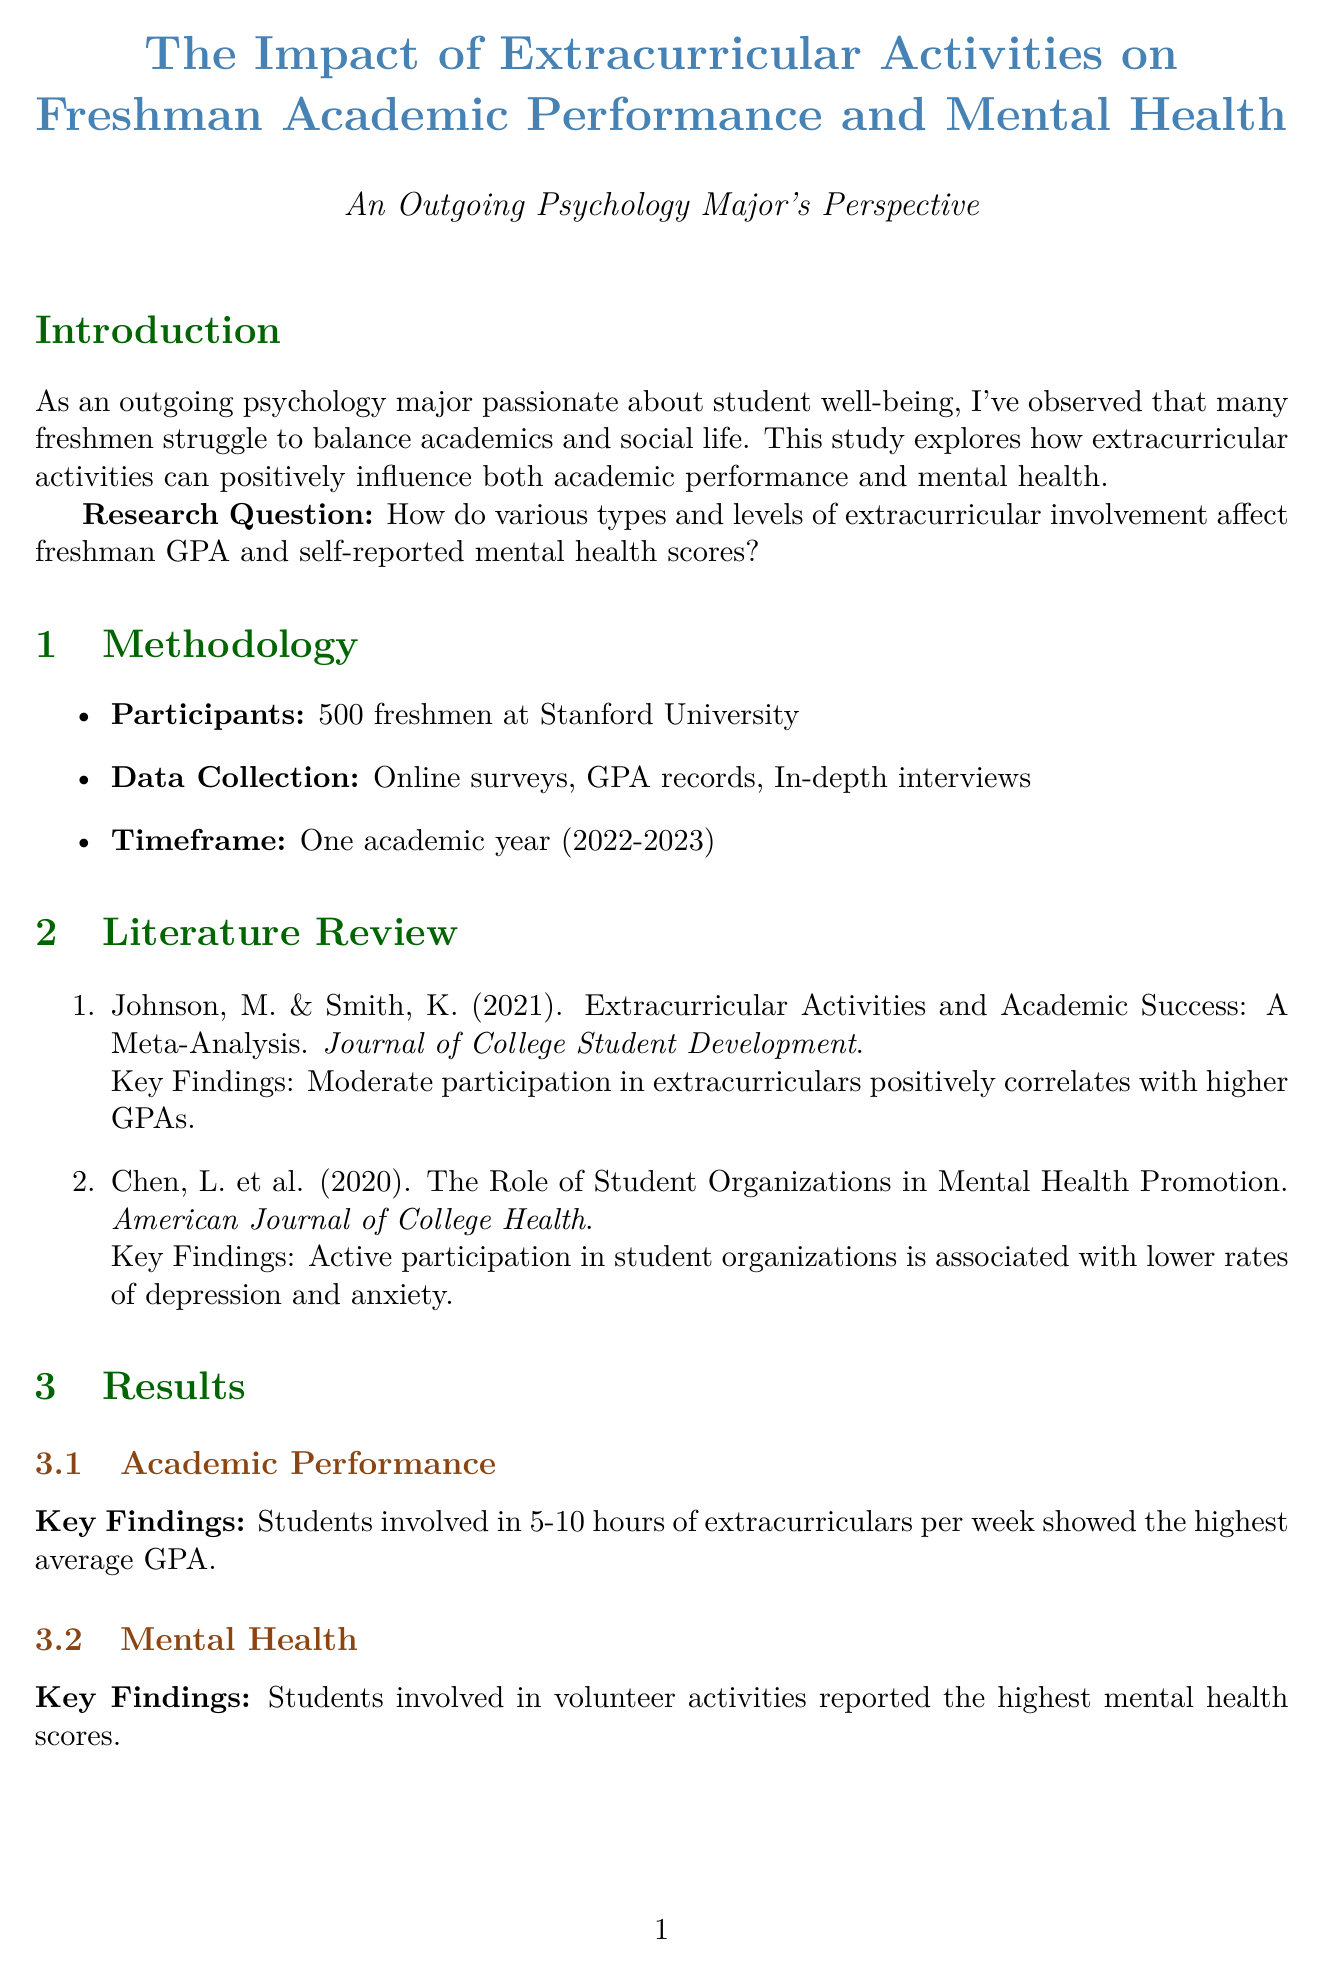What is the title of the report? The title of the report is mentioned at the top and provides the main focus of the study.
Answer: The Impact of Extracurricular Activities on Freshman Academic Performance and Mental Health How many freshmen participated in the study? The number of participants is stated in the methodology section, giving an idea of the study's scale.
Answer: 500 freshmen What was the average GPA at 10 hours of extracurricular involvement? The results section provides specific GPA scores related to hours of involvement.
Answer: 3.6 Which extracurricular category had the highest mental health score? The results include a comparison of mental health scores by activity category, highlighting the best performer.
Answer: Volunteer What GPA change did Emily Chen experience? The case study for Emily details her initial and final GPA, reflecting academic performance changes due to extracurricular activities.
Answer: Increased from 3.2 to 3.7 Why is moderate involvement emphasized in the discussion? The discussion highlights key points, focusing on the relationship between time spent in activities and academic outcomes, which includes this specific insight.
Answer: Optimal for academic performance What is one limitation of the study? The limitations section outlines specific constraints regarding the study's applicability and scope.
Answer: Study limited to one university What is a recommendation given in the conclusion? The recommendations section lists actionable advice for freshmen based on the study's findings.
Answer: Encourage freshmen to explore diverse extracurricular options 